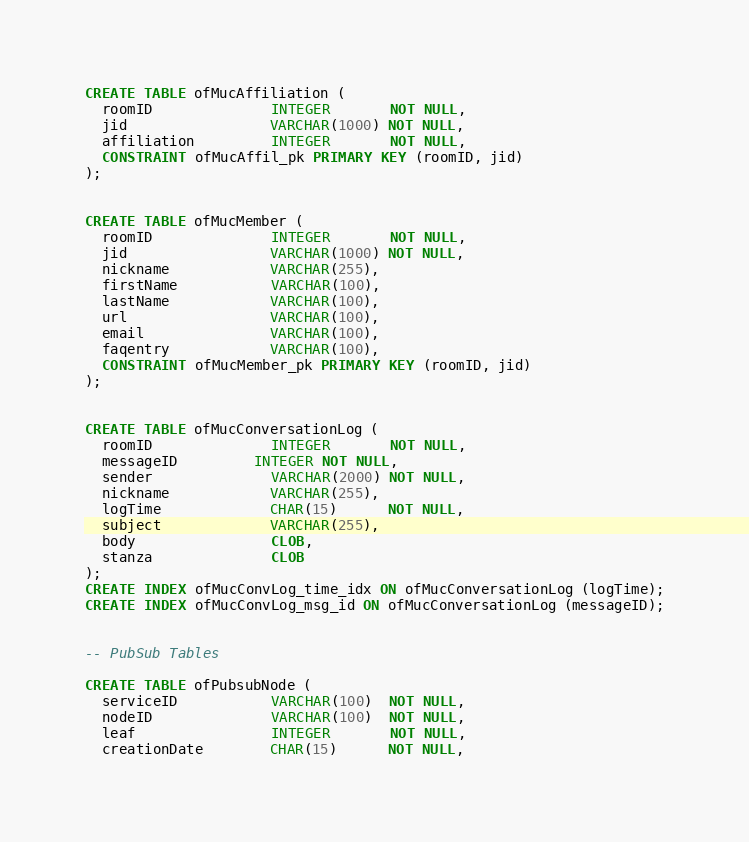<code> <loc_0><loc_0><loc_500><loc_500><_SQL_>

CREATE TABLE ofMucAffiliation (
  roomID              INTEGER       NOT NULL,
  jid                 VARCHAR(1000) NOT NULL,
  affiliation         INTEGER       NOT NULL,
  CONSTRAINT ofMucAffil_pk PRIMARY KEY (roomID, jid)
);


CREATE TABLE ofMucMember (
  roomID              INTEGER       NOT NULL,
  jid                 VARCHAR(1000) NOT NULL,
  nickname            VARCHAR(255),
  firstName           VARCHAR(100),
  lastName            VARCHAR(100),
  url                 VARCHAR(100),
  email               VARCHAR(100),
  faqentry            VARCHAR(100),
  CONSTRAINT ofMucMember_pk PRIMARY KEY (roomID, jid)
);


CREATE TABLE ofMucConversationLog (
  roomID              INTEGER       NOT NULL,
  messageID         INTEGER NOT NULL,
  sender              VARCHAR(2000) NOT NULL,
  nickname            VARCHAR(255),
  logTime             CHAR(15)      NOT NULL,
  subject             VARCHAR(255),
  body                CLOB,
  stanza              CLOB
);
CREATE INDEX ofMucConvLog_time_idx ON ofMucConversationLog (logTime);
CREATE INDEX ofMucConvLog_msg_id ON ofMucConversationLog (messageID);


-- PubSub Tables

CREATE TABLE ofPubsubNode (
  serviceID           VARCHAR(100)  NOT NULL,
  nodeID              VARCHAR(100)  NOT NULL,
  leaf                INTEGER       NOT NULL,
  creationDate        CHAR(15)      NOT NULL,</code> 